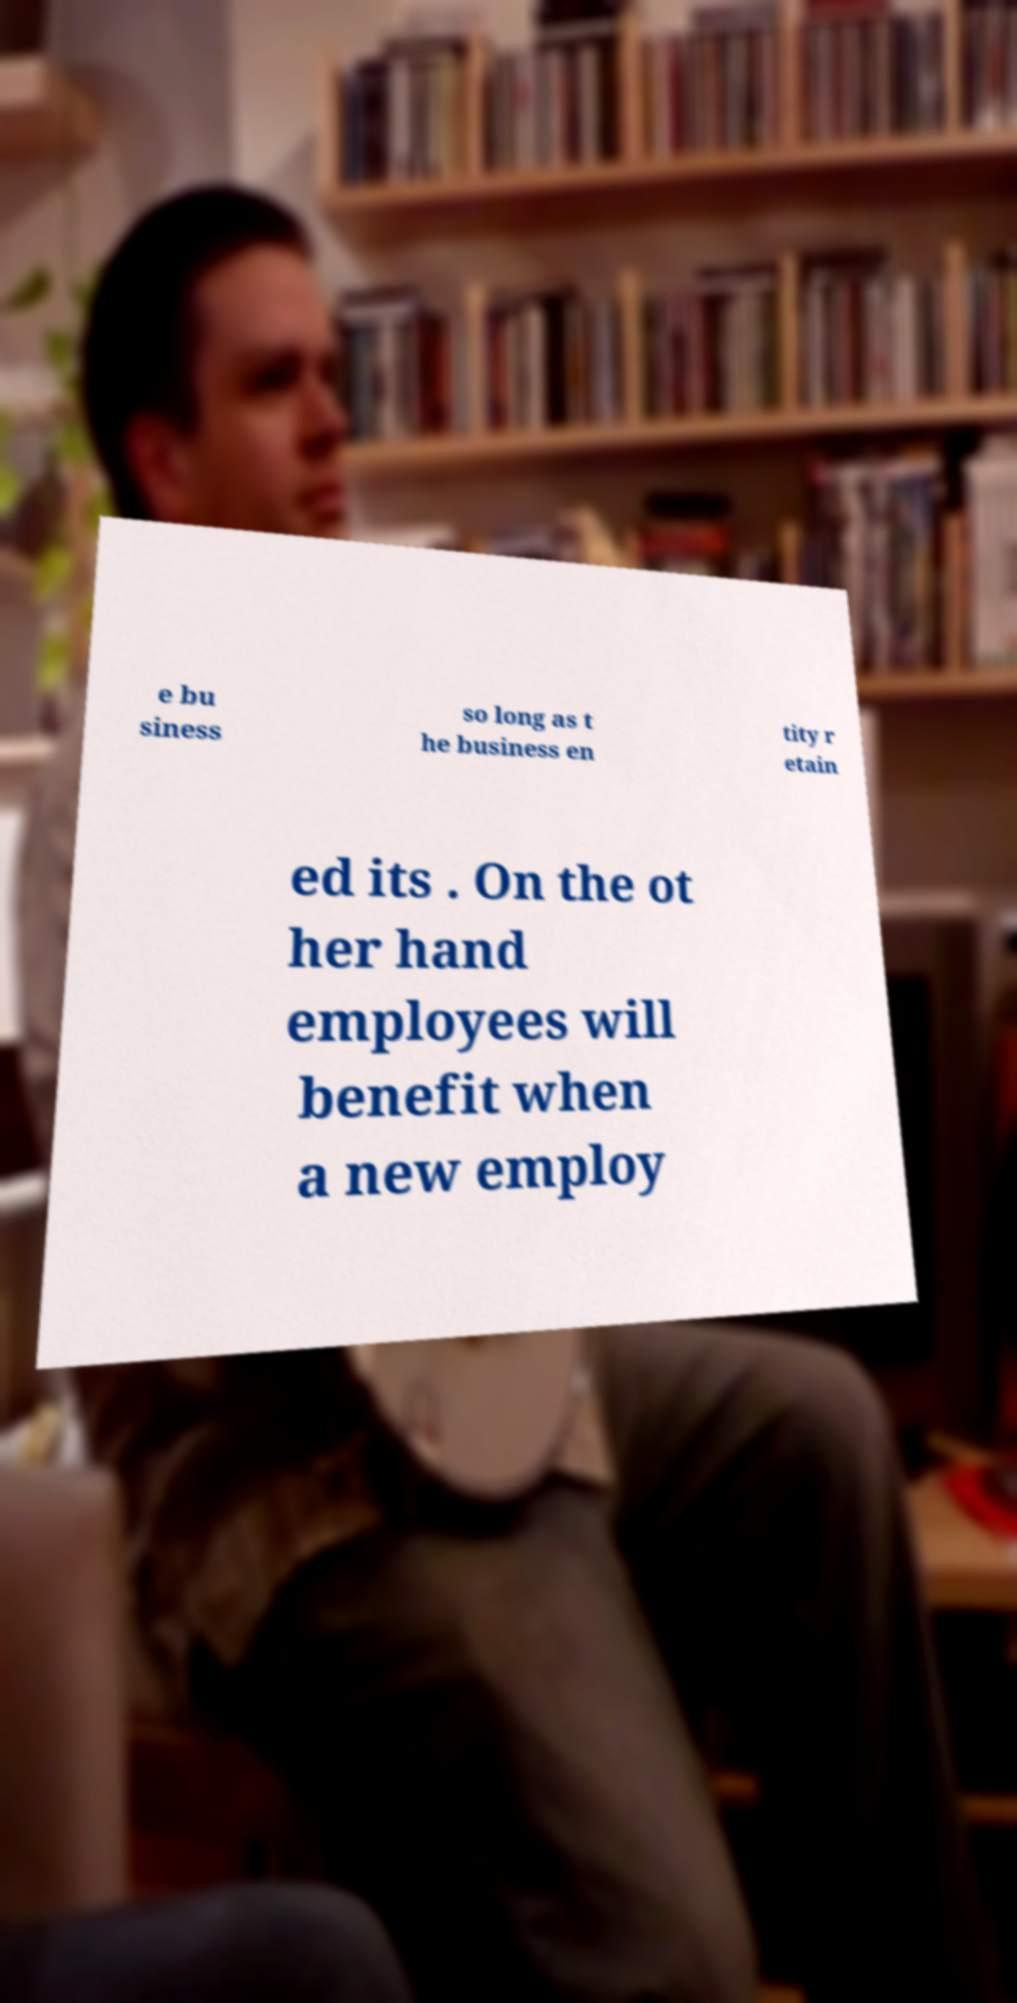Can you accurately transcribe the text from the provided image for me? e bu siness so long as t he business en tity r etain ed its . On the ot her hand employees will benefit when a new employ 